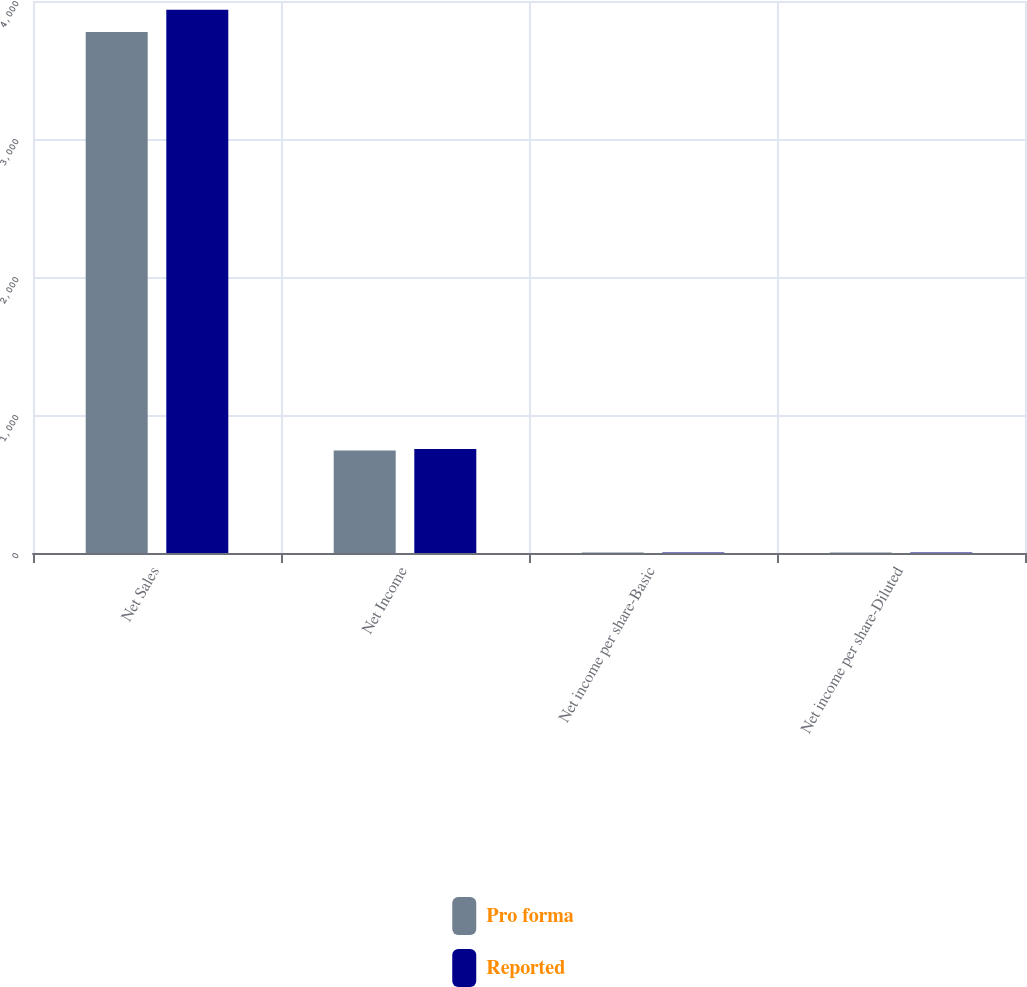Convert chart. <chart><loc_0><loc_0><loc_500><loc_500><stacked_bar_chart><ecel><fcel>Net Sales<fcel>Net Income<fcel>Net income per share-Basic<fcel>Net income per share-Diluted<nl><fcel>Pro forma<fcel>3776.2<fcel>743.4<fcel>2.97<fcel>2.9<nl><fcel>Reported<fcel>3936.2<fcel>753.4<fcel>3.01<fcel>2.94<nl></chart> 